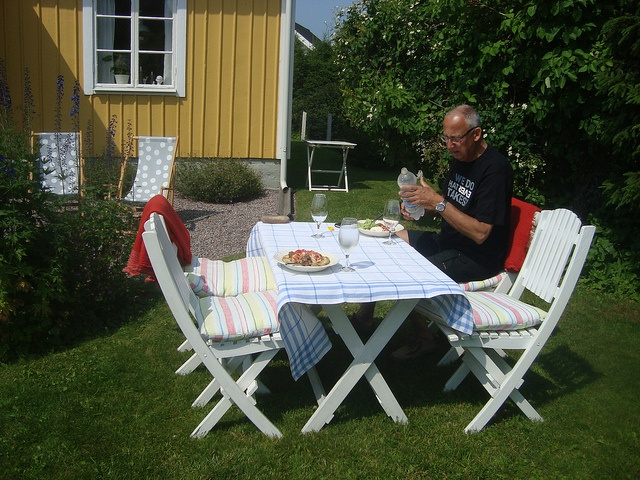Describe the objects in this image and their specific colors. I can see dining table in black, lavender, gray, and darkgray tones, potted plant in black, darkgreen, and gray tones, chair in black, lightgray, darkgray, and gray tones, people in black, gray, and maroon tones, and chair in black, darkgray, lightgray, and gray tones in this image. 